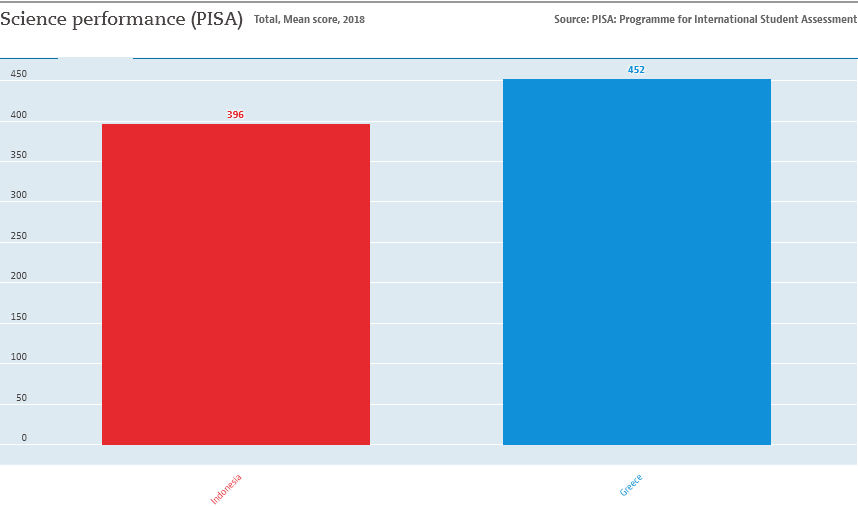Highlight a few significant elements in this photo. The difference in the value of both bars is 56. The value of the smallest bar is 396. 